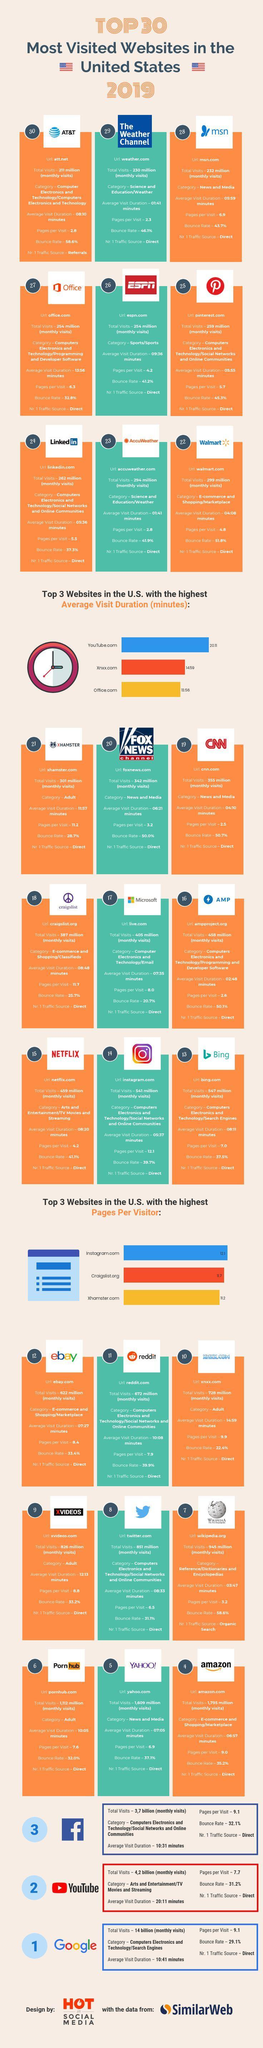Which website appears in the 8th position ?
Answer the question with a short phrase. Twitter How many website have traffic source as referrals ? 1 Which has the second highest pages per visitor between the websites Craiglist.org, Instagram.com. and Xhamster.com ? Craiglist.org Which website has the second highest average visit duration  Xnxx.com, Office.com, or YouTube.com ? Xnxx.com How many websites have traffic source as organic search? 1 Which has a higher bounce rate Youtube, Facebook, or Google? Facebook Which website appears in the 25th position? pinterest.com Which website appear in the 14th position? Instagram What is the difference in number of total monthly visits of Google and Youtube? 9.8 billion 